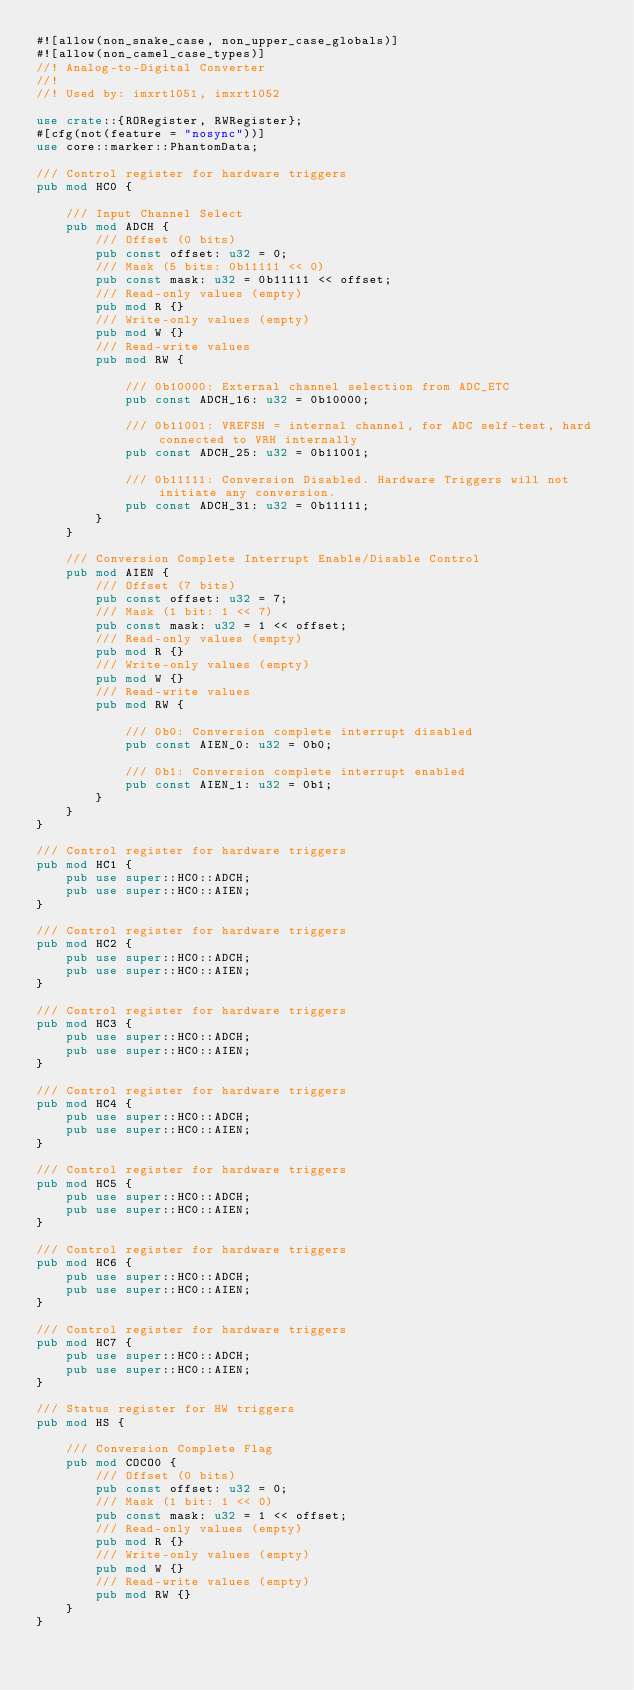<code> <loc_0><loc_0><loc_500><loc_500><_Rust_>#![allow(non_snake_case, non_upper_case_globals)]
#![allow(non_camel_case_types)]
//! Analog-to-Digital Converter
//!
//! Used by: imxrt1051, imxrt1052

use crate::{RORegister, RWRegister};
#[cfg(not(feature = "nosync"))]
use core::marker::PhantomData;

/// Control register for hardware triggers
pub mod HC0 {

    /// Input Channel Select
    pub mod ADCH {
        /// Offset (0 bits)
        pub const offset: u32 = 0;
        /// Mask (5 bits: 0b11111 << 0)
        pub const mask: u32 = 0b11111 << offset;
        /// Read-only values (empty)
        pub mod R {}
        /// Write-only values (empty)
        pub mod W {}
        /// Read-write values
        pub mod RW {

            /// 0b10000: External channel selection from ADC_ETC
            pub const ADCH_16: u32 = 0b10000;

            /// 0b11001: VREFSH = internal channel, for ADC self-test, hard connected to VRH internally
            pub const ADCH_25: u32 = 0b11001;

            /// 0b11111: Conversion Disabled. Hardware Triggers will not initiate any conversion.
            pub const ADCH_31: u32 = 0b11111;
        }
    }

    /// Conversion Complete Interrupt Enable/Disable Control
    pub mod AIEN {
        /// Offset (7 bits)
        pub const offset: u32 = 7;
        /// Mask (1 bit: 1 << 7)
        pub const mask: u32 = 1 << offset;
        /// Read-only values (empty)
        pub mod R {}
        /// Write-only values (empty)
        pub mod W {}
        /// Read-write values
        pub mod RW {

            /// 0b0: Conversion complete interrupt disabled
            pub const AIEN_0: u32 = 0b0;

            /// 0b1: Conversion complete interrupt enabled
            pub const AIEN_1: u32 = 0b1;
        }
    }
}

/// Control register for hardware triggers
pub mod HC1 {
    pub use super::HC0::ADCH;
    pub use super::HC0::AIEN;
}

/// Control register for hardware triggers
pub mod HC2 {
    pub use super::HC0::ADCH;
    pub use super::HC0::AIEN;
}

/// Control register for hardware triggers
pub mod HC3 {
    pub use super::HC0::ADCH;
    pub use super::HC0::AIEN;
}

/// Control register for hardware triggers
pub mod HC4 {
    pub use super::HC0::ADCH;
    pub use super::HC0::AIEN;
}

/// Control register for hardware triggers
pub mod HC5 {
    pub use super::HC0::ADCH;
    pub use super::HC0::AIEN;
}

/// Control register for hardware triggers
pub mod HC6 {
    pub use super::HC0::ADCH;
    pub use super::HC0::AIEN;
}

/// Control register for hardware triggers
pub mod HC7 {
    pub use super::HC0::ADCH;
    pub use super::HC0::AIEN;
}

/// Status register for HW triggers
pub mod HS {

    /// Conversion Complete Flag
    pub mod COCO0 {
        /// Offset (0 bits)
        pub const offset: u32 = 0;
        /// Mask (1 bit: 1 << 0)
        pub const mask: u32 = 1 << offset;
        /// Read-only values (empty)
        pub mod R {}
        /// Write-only values (empty)
        pub mod W {}
        /// Read-write values (empty)
        pub mod RW {}
    }
}
</code> 